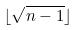Convert formula to latex. <formula><loc_0><loc_0><loc_500><loc_500>\lfloor \sqrt { n - 1 } \rfloor</formula> 